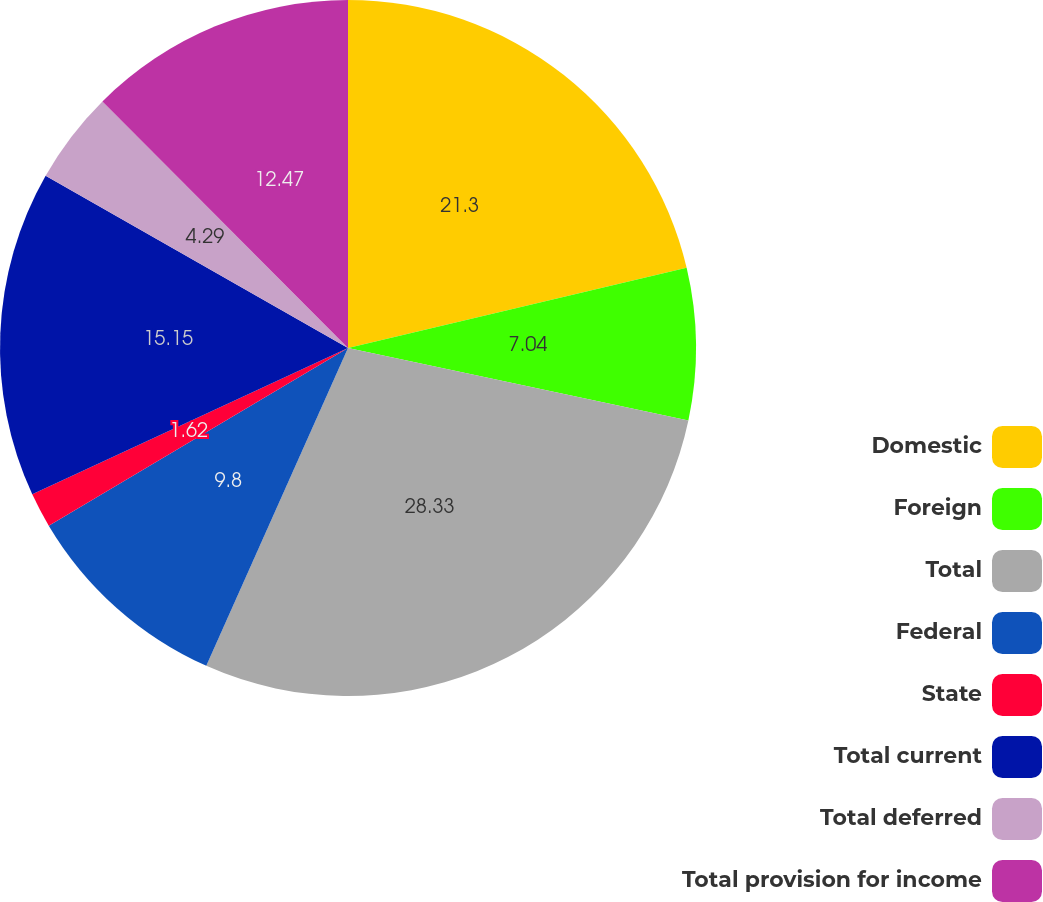<chart> <loc_0><loc_0><loc_500><loc_500><pie_chart><fcel>Domestic<fcel>Foreign<fcel>Total<fcel>Federal<fcel>State<fcel>Total current<fcel>Total deferred<fcel>Total provision for income<nl><fcel>21.3%<fcel>7.04%<fcel>28.34%<fcel>9.8%<fcel>1.62%<fcel>15.15%<fcel>4.29%<fcel>12.47%<nl></chart> 